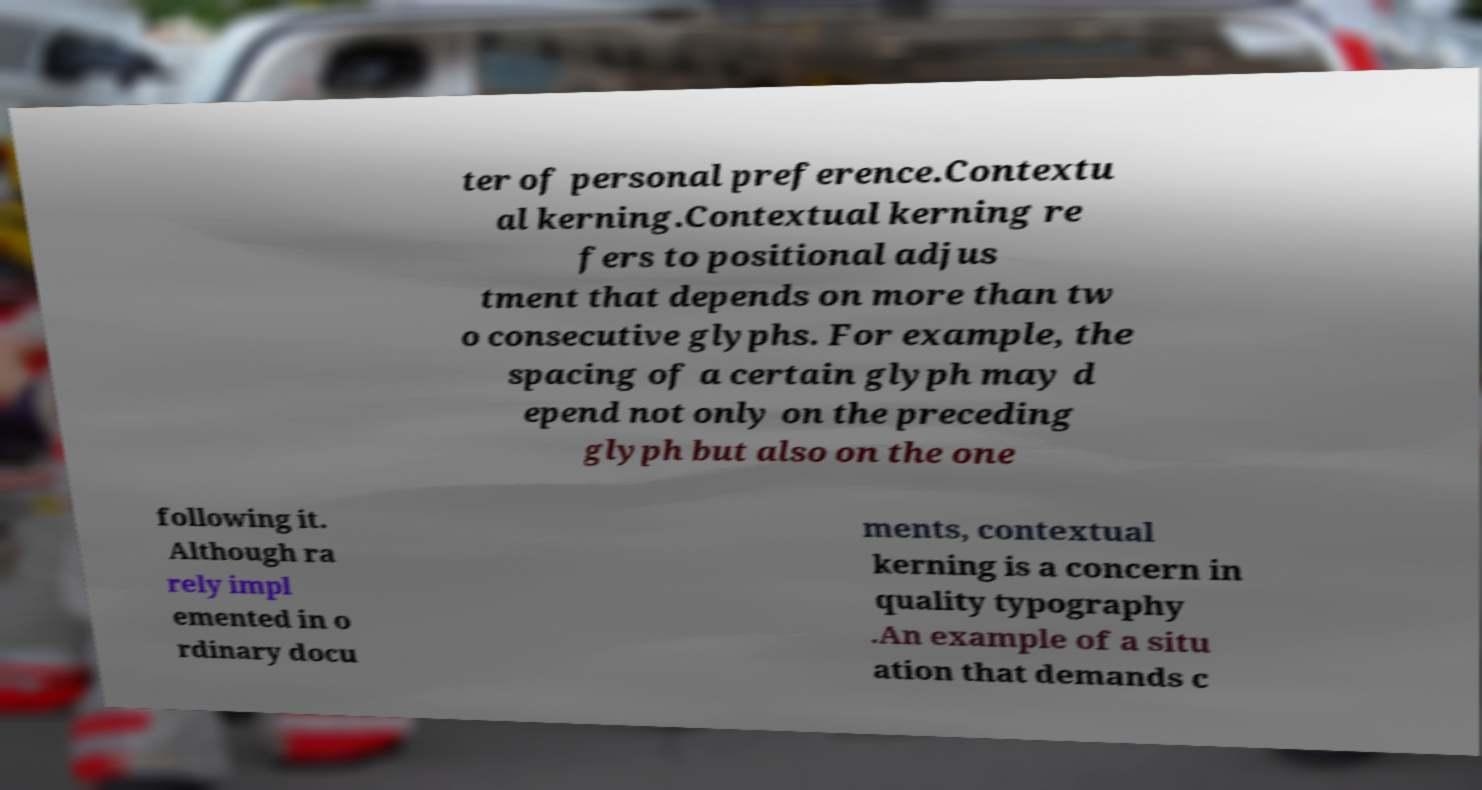There's text embedded in this image that I need extracted. Can you transcribe it verbatim? ter of personal preference.Contextu al kerning.Contextual kerning re fers to positional adjus tment that depends on more than tw o consecutive glyphs. For example, the spacing of a certain glyph may d epend not only on the preceding glyph but also on the one following it. Although ra rely impl emented in o rdinary docu ments, contextual kerning is a concern in quality typography .An example of a situ ation that demands c 